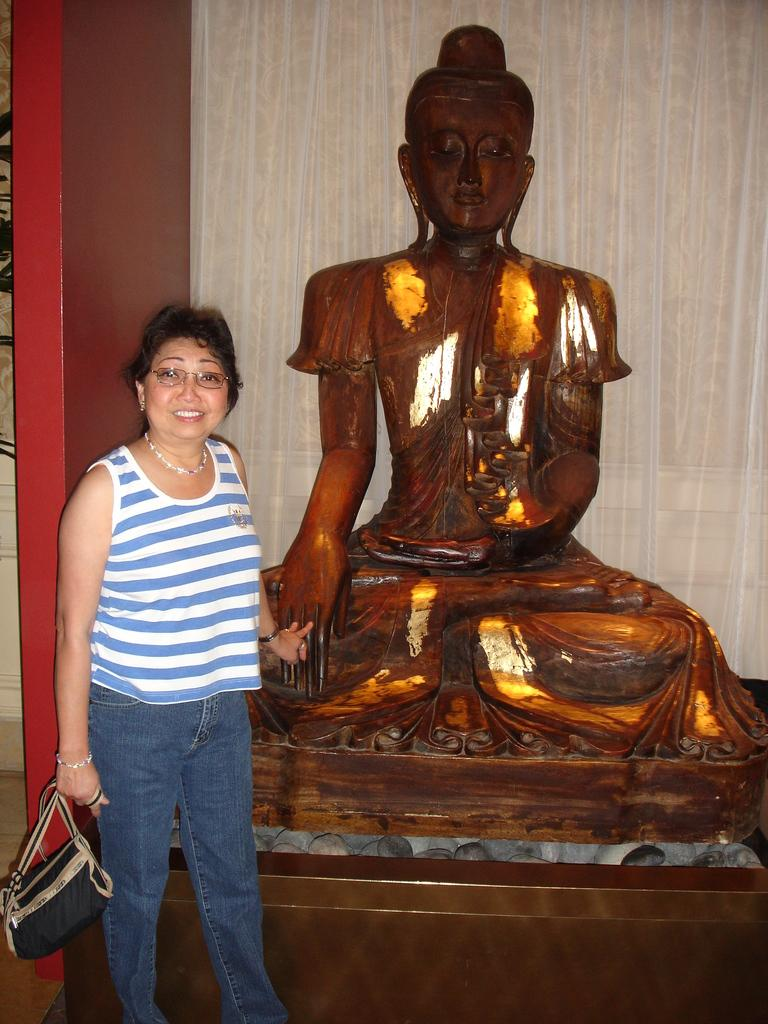What is there is a woman in the image, what is she doing? The woman in the image is standing on the floor and smiling. What is the woman wearing in the image? The woman is wearing spectacles. What is the woman holding in the image? The woman is holding a bag. What is the nature of the image? The image is of a sculpture. What other object is present in the image? There is a cloth present in the image. How does the woman use the rice in the image? There is no rice present in the image, so it cannot be used by the woman. 